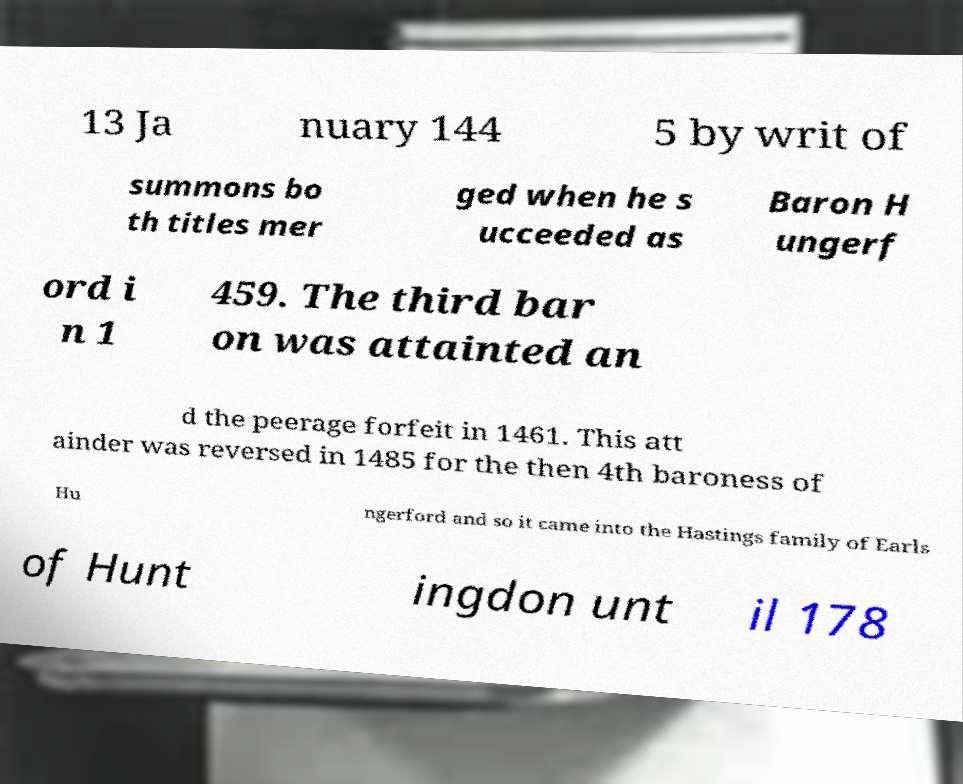Can you read and provide the text displayed in the image?This photo seems to have some interesting text. Can you extract and type it out for me? 13 Ja nuary 144 5 by writ of summons bo th titles mer ged when he s ucceeded as Baron H ungerf ord i n 1 459. The third bar on was attainted an d the peerage forfeit in 1461. This att ainder was reversed in 1485 for the then 4th baroness of Hu ngerford and so it came into the Hastings family of Earls of Hunt ingdon unt il 178 